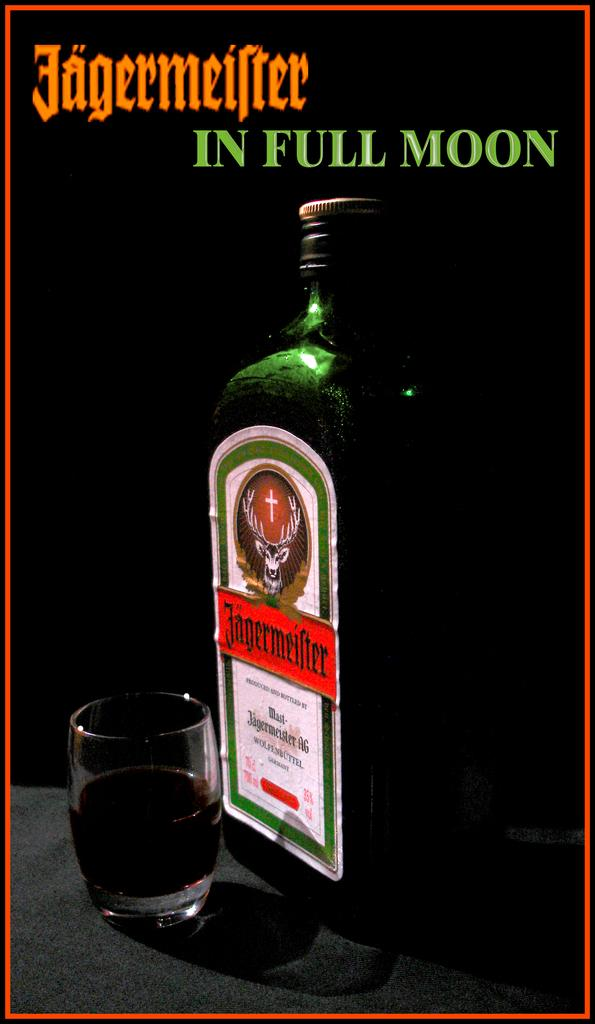What object can be seen in the image? There is a bottle in the image. What color is the bottle? The bottle is green in color. What is inside the bottle? There is a glass at the bottom of the bottle. What is in the glass? There is liquid in the glass. What can be seen written at the top of the bottle? There is something written at the top of the bottle. How many children are playing with the bottle in the image? There are no children present in the image; it only features a bottle with a glass and liquid inside. 